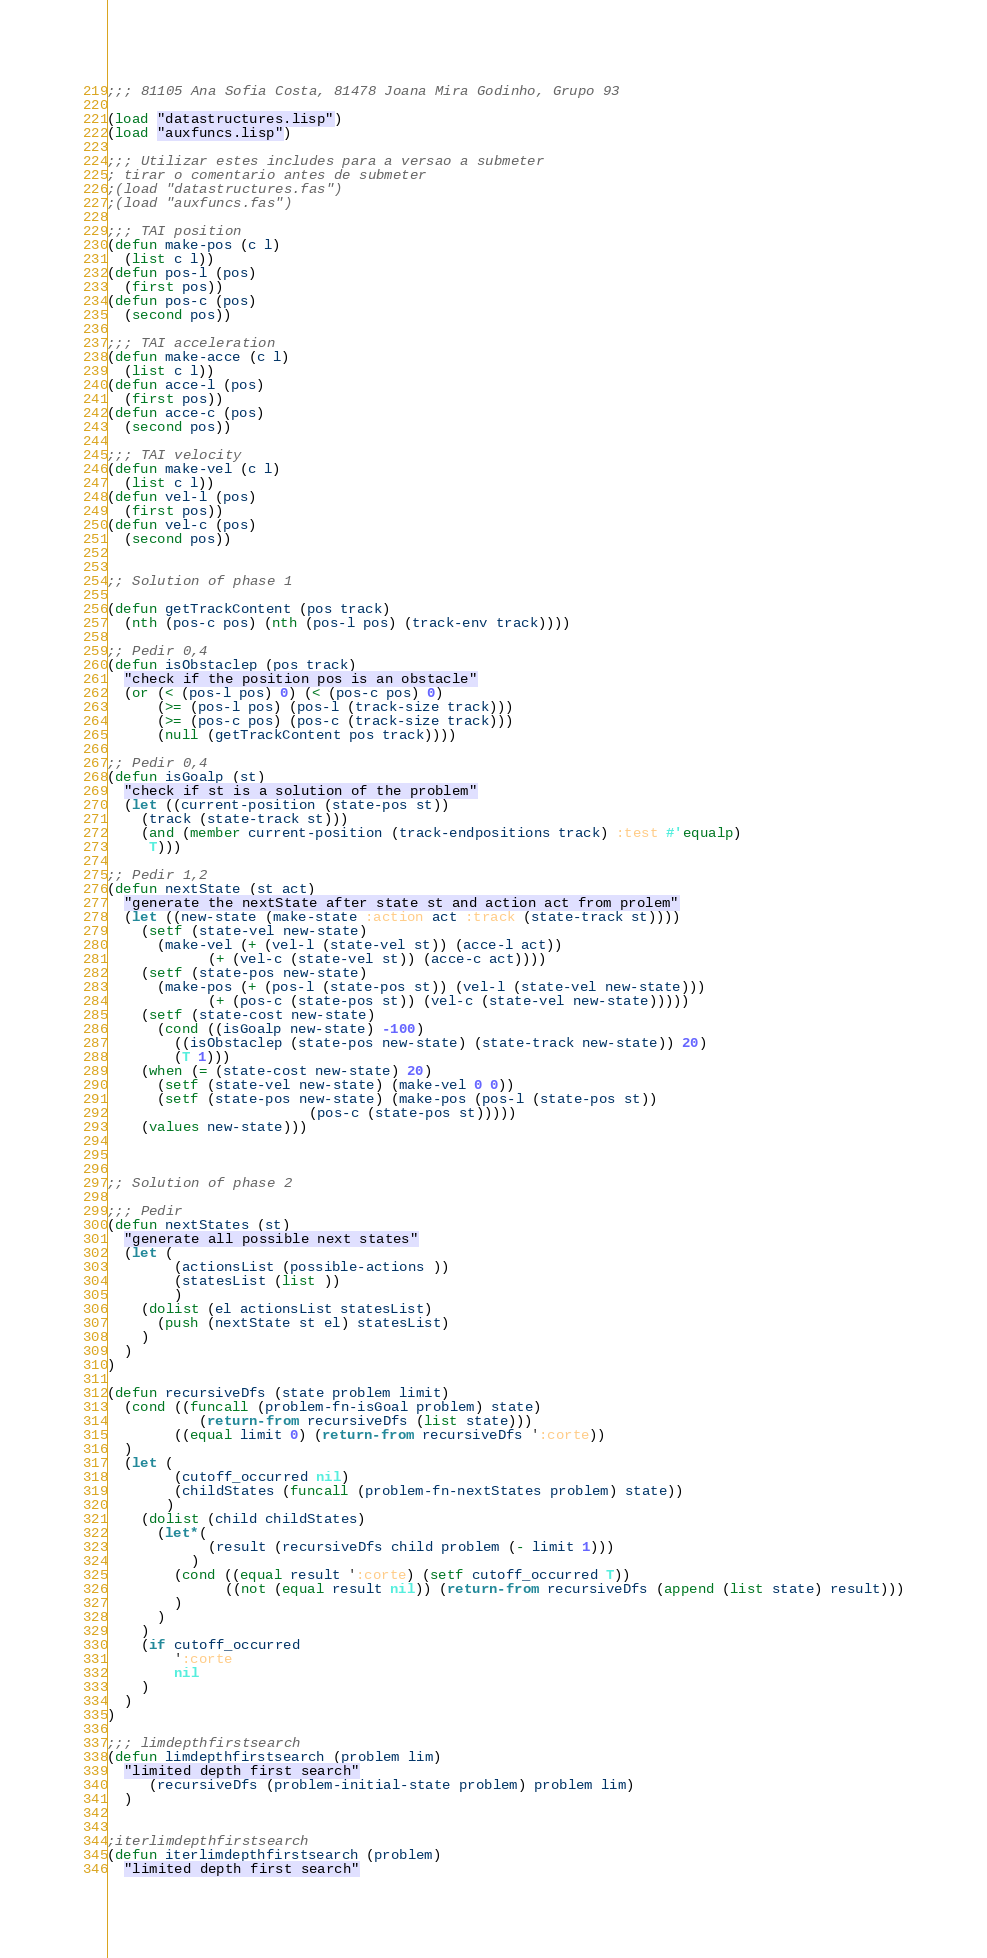<code> <loc_0><loc_0><loc_500><loc_500><_Lisp_>;;; 81105 Ana Sofia Costa, 81478 Joana Mira Godinho, Grupo 93

(load "datastructures.lisp")
(load "auxfuncs.lisp")

;;; Utilizar estes includes para a versao a submeter
; tirar o comentario antes de submeter
;(load "datastructures.fas")
;(load "auxfuncs.fas")

;;; TAI position
(defun make-pos (c l)
  (list c l))
(defun pos-l (pos)
  (first pos))
(defun pos-c (pos)
  (second pos))

;;; TAI acceleration
(defun make-acce (c l)
  (list c l))
(defun acce-l (pos)
  (first pos))
(defun acce-c (pos)
  (second pos))

;;; TAI velocity
(defun make-vel (c l)
  (list c l))
(defun vel-l (pos)
  (first pos))
(defun vel-c (pos)
  (second pos))


;; Solution of phase 1

(defun getTrackContent (pos track)
  (nth (pos-c pos) (nth (pos-l pos) (track-env track))))

;; Pedir 0,4
(defun isObstaclep (pos track)
  "check if the position pos is an obstacle"
  (or (< (pos-l pos) 0) (< (pos-c pos) 0)
      (>= (pos-l pos) (pos-l (track-size track)))
      (>= (pos-c pos) (pos-c (track-size track)))
      (null (getTrackContent pos track))))

;; Pedir 0,4
(defun isGoalp (st)
  "check if st is a solution of the problem"
  (let ((current-position (state-pos st))
	(track (state-track st)))
    (and (member current-position (track-endpositions track) :test #'equalp)
	 T)))

;; Pedir 1,2
(defun nextState (st act)
  "generate the nextState after state st and action act from prolem"
  (let ((new-state (make-state :action act :track (state-track st))))
    (setf (state-vel new-state)
	  (make-vel (+ (vel-l (state-vel st)) (acce-l act))
		    (+ (vel-c (state-vel st)) (acce-c act))))
    (setf (state-pos new-state)
	  (make-pos (+ (pos-l (state-pos st)) (vel-l (state-vel new-state)))
		    (+ (pos-c (state-pos st)) (vel-c (state-vel new-state)))))
    (setf (state-cost new-state)
	  (cond ((isGoalp new-state) -100)
		((isObstaclep (state-pos new-state) (state-track new-state)) 20)
		(T 1)))
    (when (= (state-cost new-state) 20)
      (setf (state-vel new-state) (make-vel 0 0))
      (setf (state-pos new-state) (make-pos (pos-l (state-pos st))
					    (pos-c (state-pos st)))))
    (values new-state)))



;; Solution of phase 2

;;; Pedir
(defun nextStates (st)
  "generate all possible next states"
  (let (
        (actionsList (possible-actions ))
        (statesList (list ))
        )
    (dolist (el actionsList statesList)
      (push (nextState st el) statesList)
    )
  )
)

(defun recursiveDfs (state problem limit)
  (cond ((funcall (problem-fn-isGoal problem) state)
           (return-from recursiveDfs (list state)))
        ((equal limit 0) (return-from recursiveDfs ':corte))
  )
  (let (
        (cutoff_occurred nil)
        (childStates (funcall (problem-fn-nextStates problem) state))
       )
    (dolist (child childStates)
      (let*(
            (result (recursiveDfs child problem (- limit 1)))
          )
        (cond ((equal result ':corte) (setf cutoff_occurred T))
              ((not (equal result nil)) (return-from recursiveDfs (append (list state) result)))
        )
      )
    )
    (if cutoff_occurred
        ':corte
        nil
    )
  )
)

;;; limdepthfirstsearch
(defun limdepthfirstsearch (problem lim)
  "limited depth first search"
     (recursiveDfs (problem-initial-state problem) problem lim)
  )


;iterlimdepthfirstsearch
(defun iterlimdepthfirstsearch (problem)
  "limited depth first search"</code> 